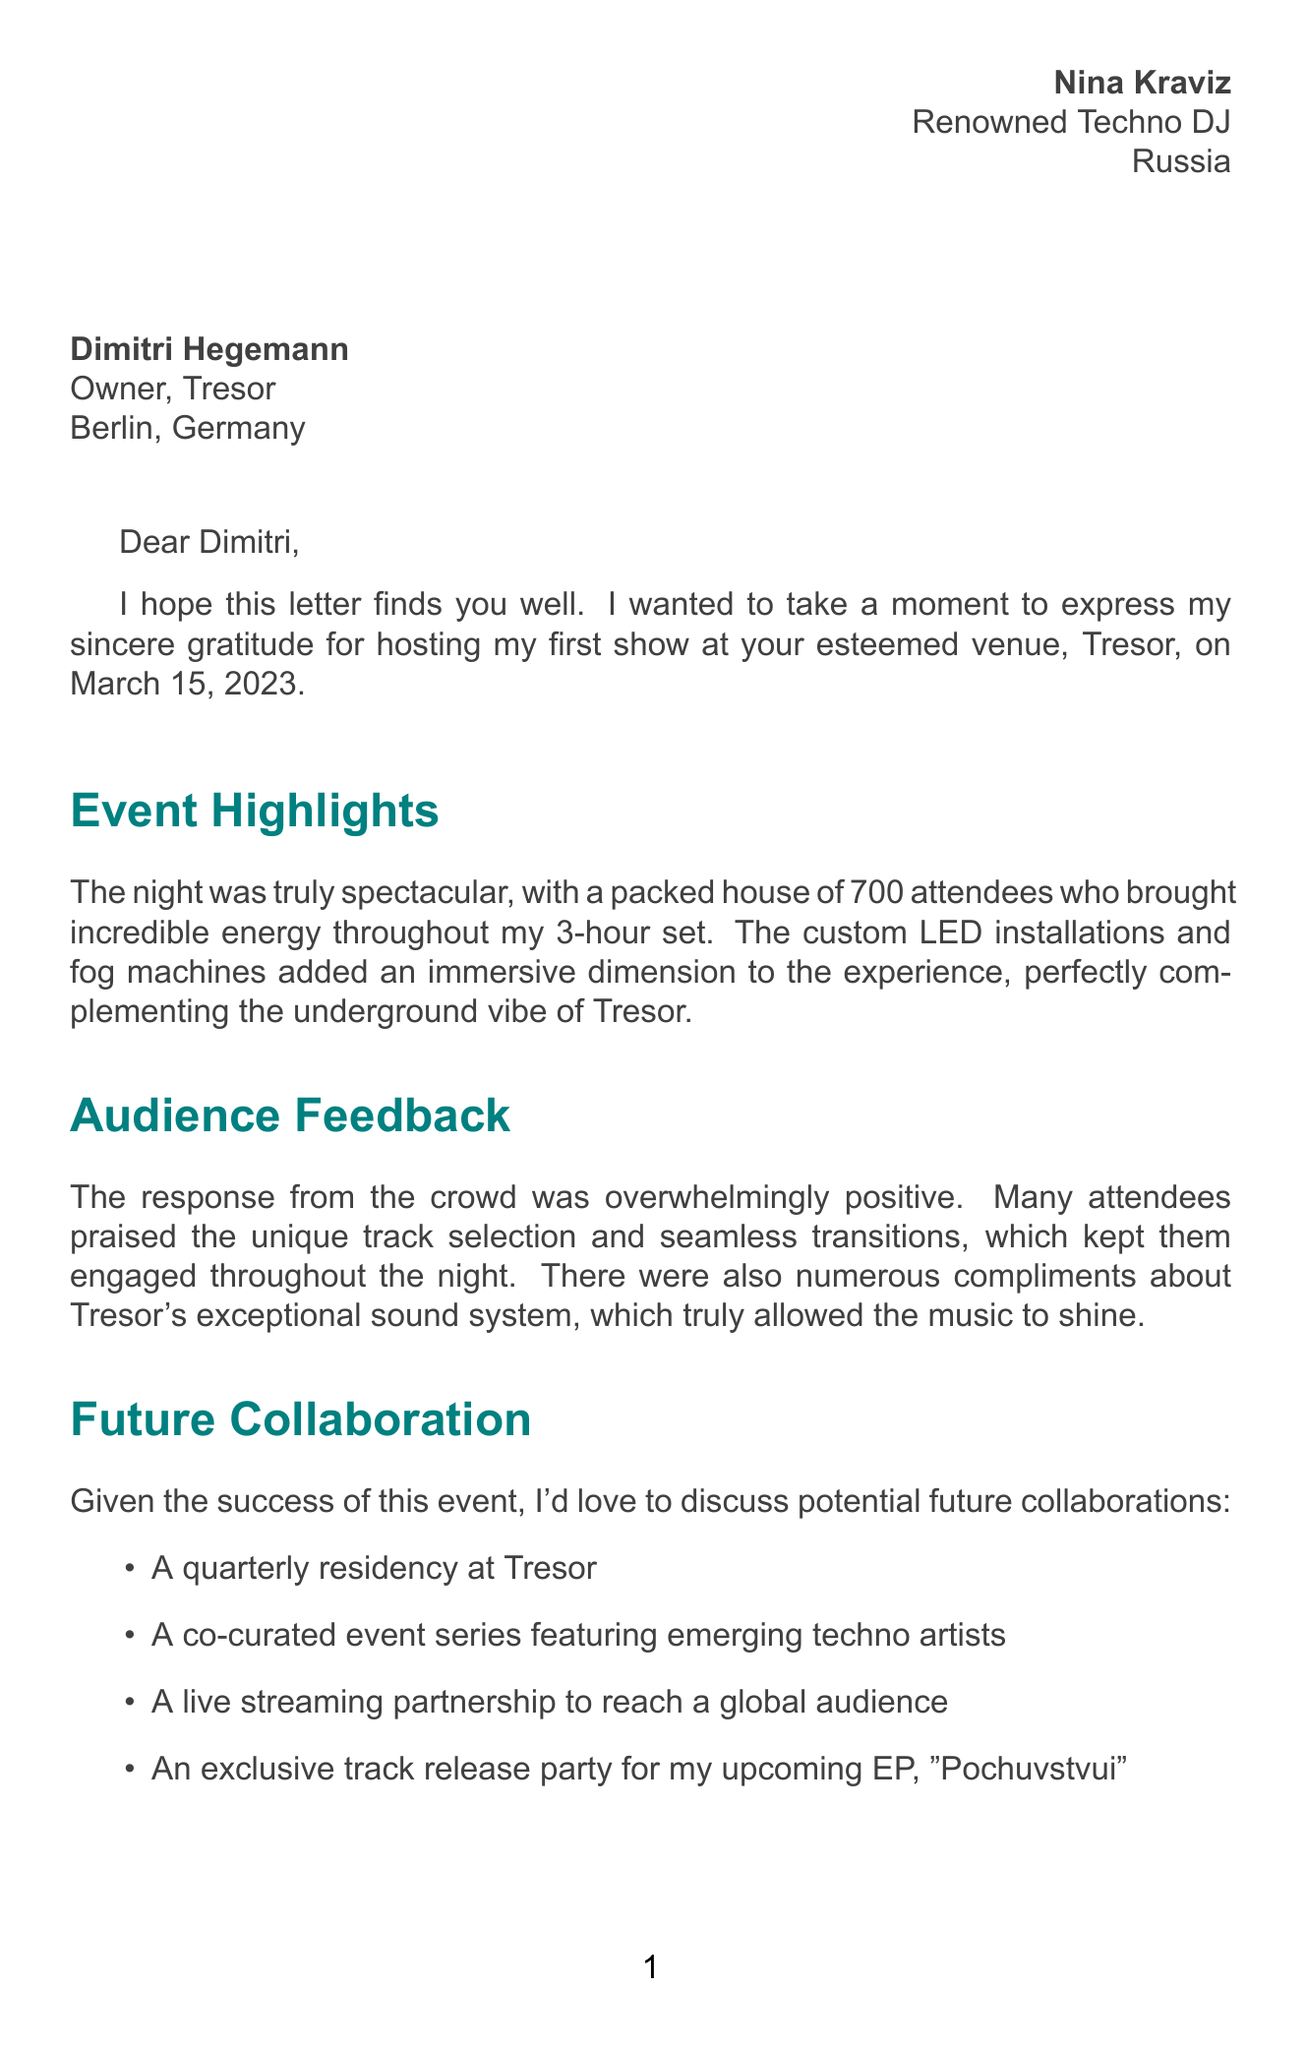What is the name of the DJ? The DJ's name is mentioned in the signature of the letter.
Answer: Nina Kraviz What genre of music does Nina Kraviz play? The genre is specified in the details provided in the document.
Answer: Techno When did the event take place? The date of the event is clearly stated in the opening of the letter.
Answer: March 15, 2023 How many attendees were at the event? The letter states the number of attendees present during the show.
Answer: 700 What is the capacity of the Tresor club? The capacity of the club is provided in the club details section.
Answer: 750 What is one idea for future collaboration mentioned in the letter? This requires referencing the future collaboration ideas listed in the body of the letter.
Answer: Quarterly residency at Tresor What lighting effects were used during the show? The special effects utilized for the event are outlined in the description.
Answer: Custom LED installations and fog machines How long did Nina's set last? The duration of the DJ's set is included in the event details.
Answer: 3 hours What year was Tresor established? The document mentions the year the club was established.
Answer: 1991 